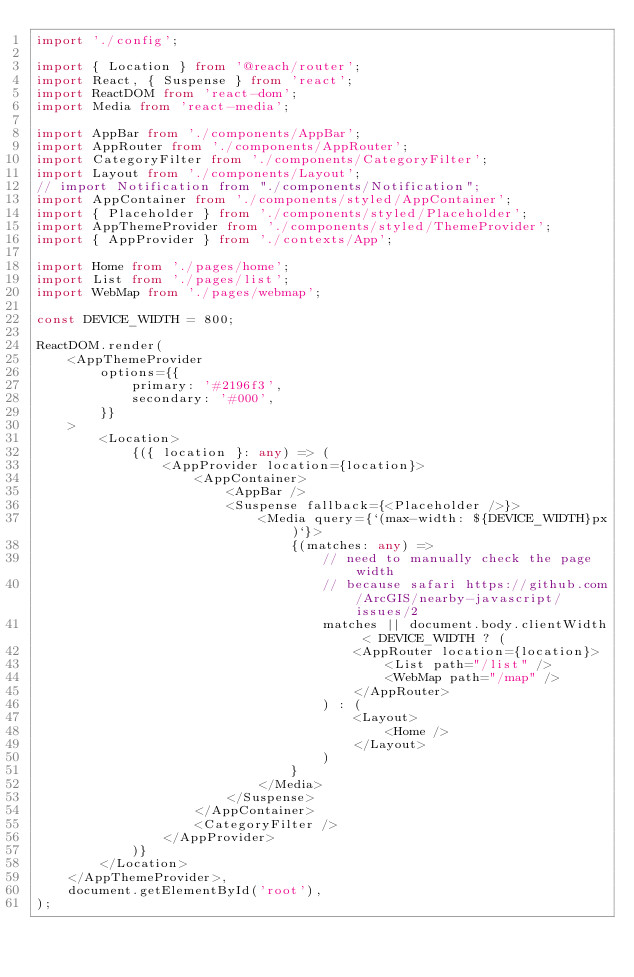Convert code to text. <code><loc_0><loc_0><loc_500><loc_500><_TypeScript_>import './config';

import { Location } from '@reach/router';
import React, { Suspense } from 'react';
import ReactDOM from 'react-dom';
import Media from 'react-media';

import AppBar from './components/AppBar';
import AppRouter from './components/AppRouter';
import CategoryFilter from './components/CategoryFilter';
import Layout from './components/Layout';
// import Notification from "./components/Notification";
import AppContainer from './components/styled/AppContainer';
import { Placeholder } from './components/styled/Placeholder';
import AppThemeProvider from './components/styled/ThemeProvider';
import { AppProvider } from './contexts/App';

import Home from './pages/home';
import List from './pages/list';
import WebMap from './pages/webmap';

const DEVICE_WIDTH = 800;

ReactDOM.render(
    <AppThemeProvider
        options={{
            primary: '#2196f3',
            secondary: '#000',
        }}
    >
        <Location>
            {({ location }: any) => (
                <AppProvider location={location}>
                    <AppContainer>
                        <AppBar />
                        <Suspense fallback={<Placeholder />}>
                            <Media query={`(max-width: ${DEVICE_WIDTH}px)`}>
                                {(matches: any) =>
                                    // need to manually check the page width
                                    // because safari https://github.com/ArcGIS/nearby-javascript/issues/2
                                    matches || document.body.clientWidth < DEVICE_WIDTH ? (
                                        <AppRouter location={location}>
                                            <List path="/list" />
                                            <WebMap path="/map" />
                                        </AppRouter>
                                    ) : (
                                        <Layout>
                                            <Home />
                                        </Layout>
                                    )
                                }
                            </Media>
                        </Suspense>
                    </AppContainer>
                    <CategoryFilter />
                </AppProvider>
            )}
        </Location>
    </AppThemeProvider>,
    document.getElementById('root'),
);
</code> 